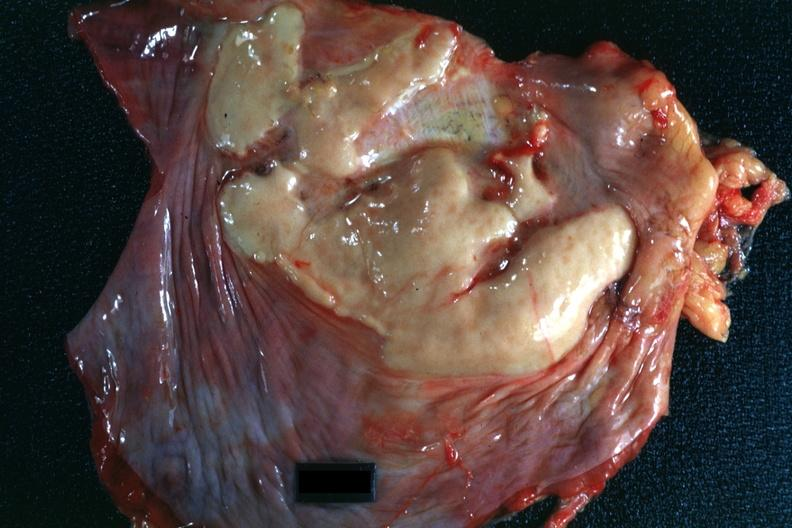s soft tissue present?
Answer the question using a single word or phrase. Yes 